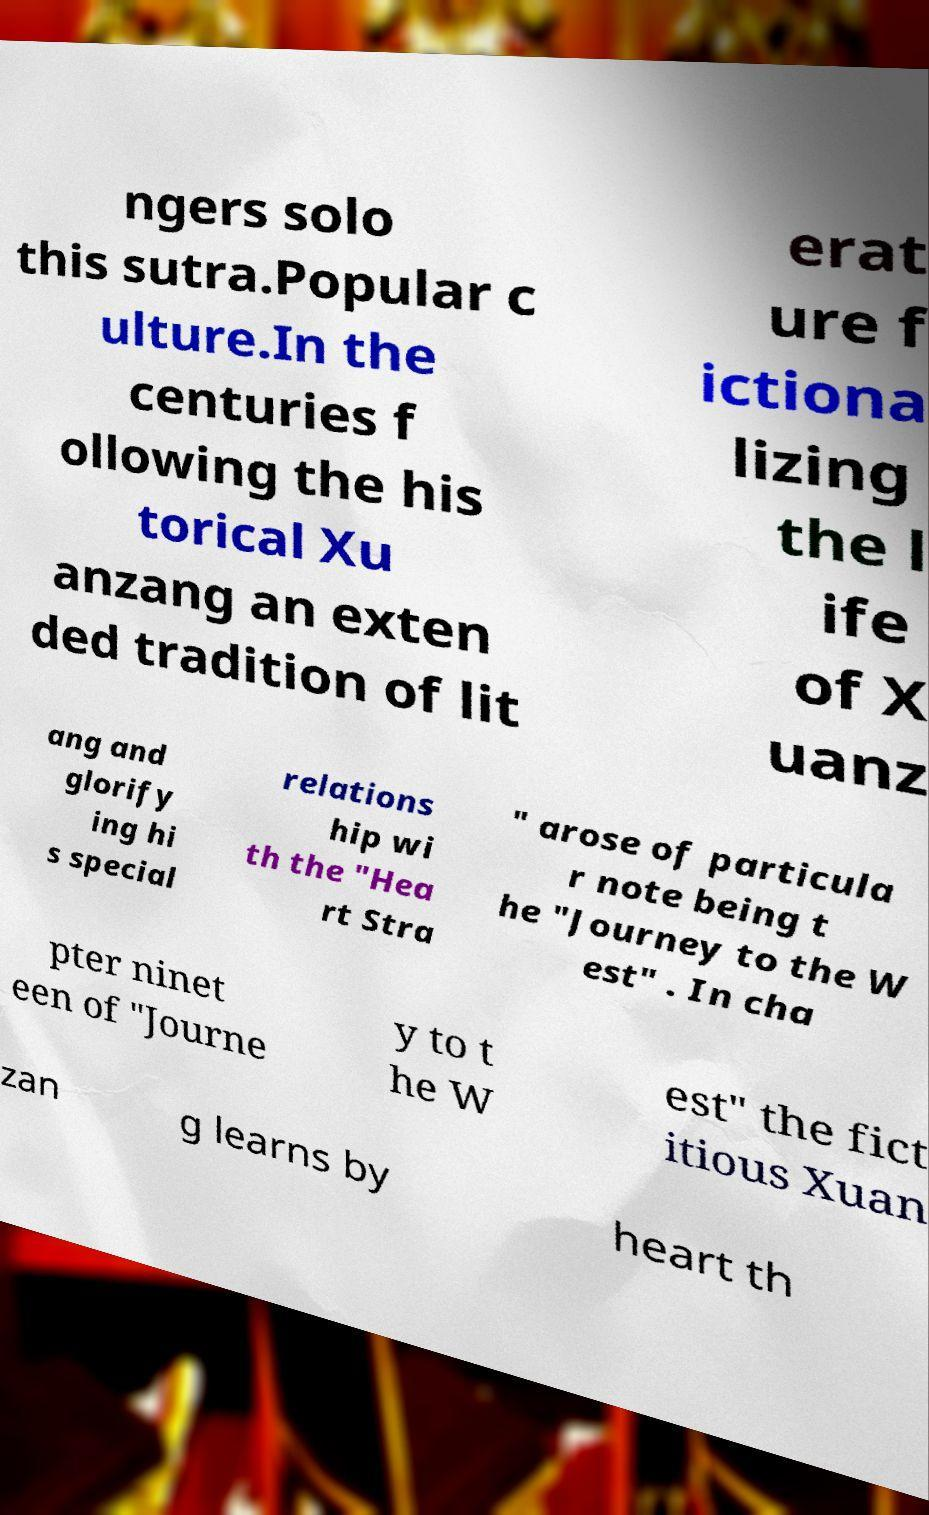Please identify and transcribe the text found in this image. ngers solo this sutra.Popular c ulture.In the centuries f ollowing the his torical Xu anzang an exten ded tradition of lit erat ure f ictiona lizing the l ife of X uanz ang and glorify ing hi s special relations hip wi th the "Hea rt Stra " arose of particula r note being t he "Journey to the W est" . In cha pter ninet een of "Journe y to t he W est" the fict itious Xuan zan g learns by heart th 